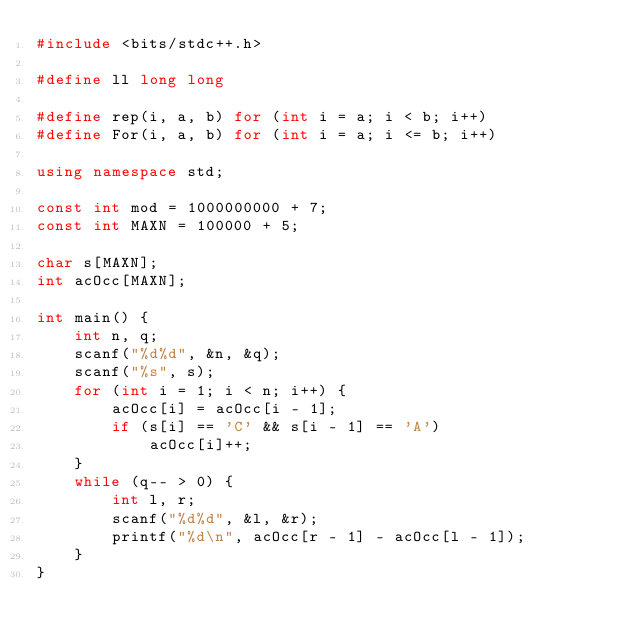Convert code to text. <code><loc_0><loc_0><loc_500><loc_500><_C++_>#include <bits/stdc++.h>

#define ll long long

#define rep(i, a, b) for (int i = a; i < b; i++)
#define For(i, a, b) for (int i = a; i <= b; i++)

using namespace std;

const int mod = 1000000000 + 7;
const int MAXN = 100000 + 5;

char s[MAXN];
int acOcc[MAXN];

int main() {
    int n, q;
    scanf("%d%d", &n, &q);
    scanf("%s", s);
    for (int i = 1; i < n; i++) {
        acOcc[i] = acOcc[i - 1];
        if (s[i] == 'C' && s[i - 1] == 'A')
            acOcc[i]++;
    }
    while (q-- > 0) {
        int l, r;
        scanf("%d%d", &l, &r);
        printf("%d\n", acOcc[r - 1] - acOcc[l - 1]);
    }
}</code> 